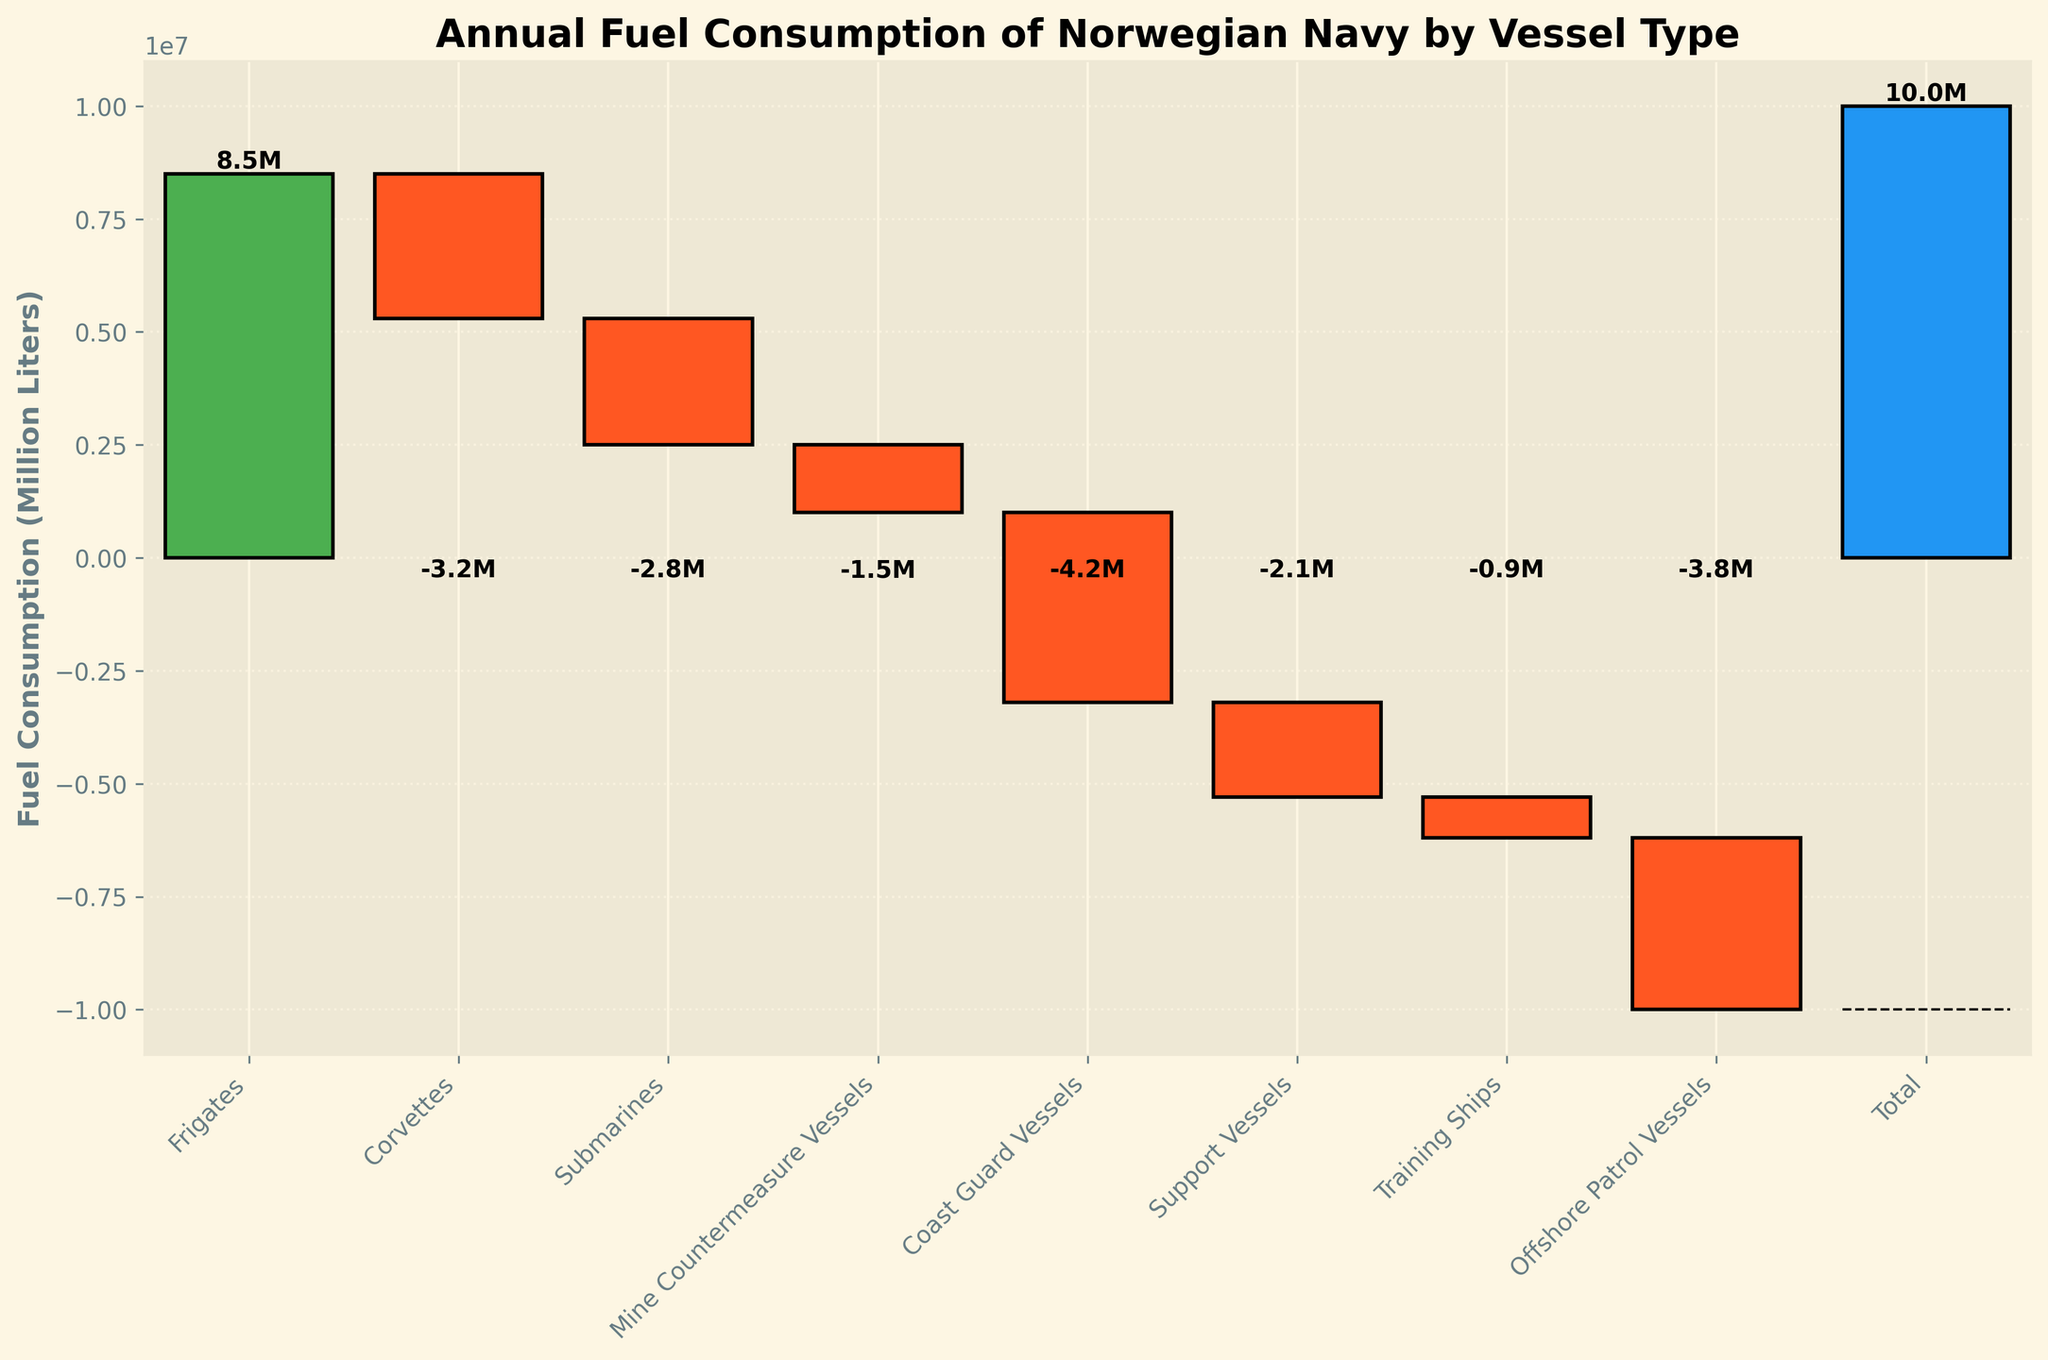What is the vessel type with the highest positive fuel consumption? To determine which vessel type has the highest positive fuel consumption, look for the tallest green bar. The green bars indicate positive consumption, and the tallest one corresponds to "Frigates" with 8.5 million liters.
Answer: Frigates What is the color of the bar representing the total fuel consumption? The color used for the bar representing the total fuel consumption is blue, indicating the overall consumption.
Answer: Blue How many vessel types have a negative fuel consumption? To count the vessel types with negative fuel consumption, identify the bars that are red. There are 7 such bars.
Answer: 7 By how much does the fuel consumption of Corvettes differ from that of Submarines? Calculate the difference between the consumption for Corvettes and Submarines. Corvettes: -3.2 million liters, Submarines: -2.8 million liters. The difference is -3.2 - (-2.8) = -0.4 million liters.
Answer: 0.4 million liters What is the total of positive fuel consumption values? The positive value is for "Frigates" with 8.5 million liters. Summing this gives 8.5 million liters.
Answer: 8.5 million liters Which vessel type has the smallest fuel consumption? Identify the vessel type with the smallest (most negative) red bar. This corresponds to "Training Ships" with -0.9 million liters.
Answer: Training Ships What is the difference between the highest and lowest fuel consumption values? The highest value is 8.5 million liters (Frigates), and the lowest (smallest negative) is -4.2 million liters (Coast Guard Vessels). Difference: 8.5 - (-4.2) = 12.7 million liters.
Answer: 12.7 million liters Which vessel type falls in the middle if you rank them based on their fuel consumption values? First, rank the values: Frigates 8.5M, Training Ships -0.9M, Mine Countermeasure Vessels -1.5M, Support Vessels -2.1M, Submarines -2.8M, Offshore Patrol Vessels -3.8M, Corvettes -3.2M, Coast Guard Vessels -4.2M. The middle vessel (5th in a list of 8) is "Submarines".
Answer: Submarines 